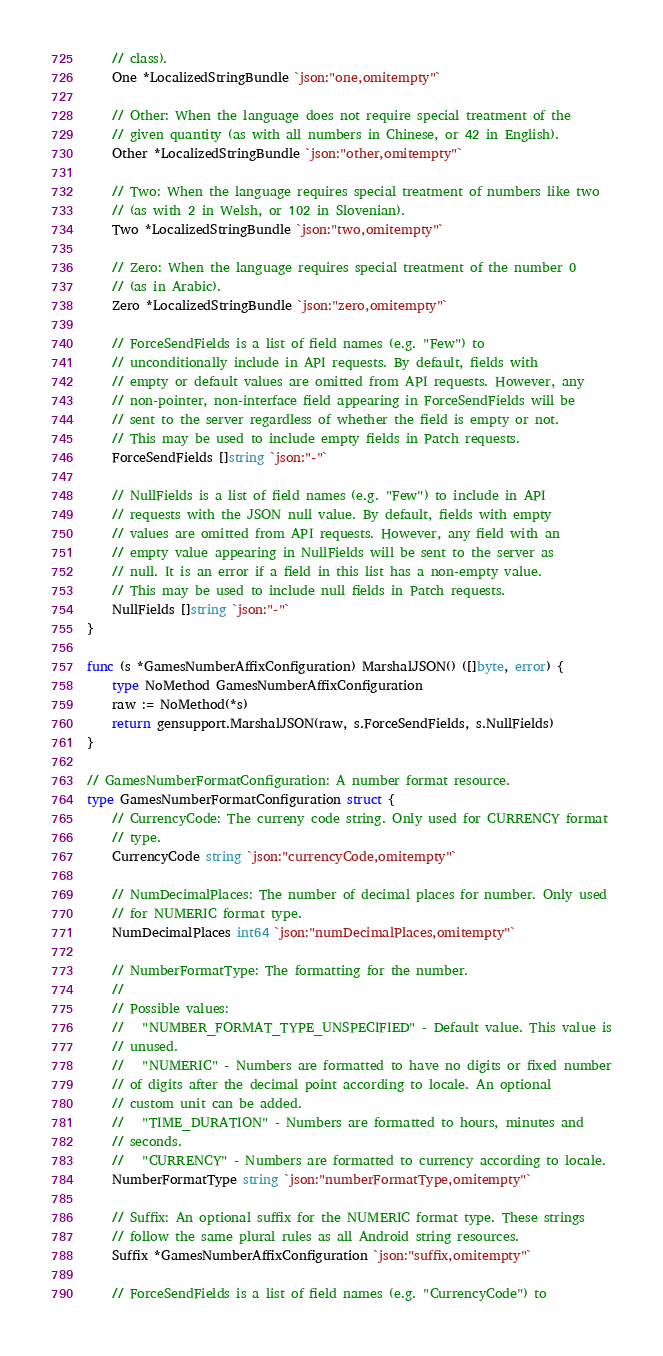Convert code to text. <code><loc_0><loc_0><loc_500><loc_500><_Go_>	// class).
	One *LocalizedStringBundle `json:"one,omitempty"`

	// Other: When the language does not require special treatment of the
	// given quantity (as with all numbers in Chinese, or 42 in English).
	Other *LocalizedStringBundle `json:"other,omitempty"`

	// Two: When the language requires special treatment of numbers like two
	// (as with 2 in Welsh, or 102 in Slovenian).
	Two *LocalizedStringBundle `json:"two,omitempty"`

	// Zero: When the language requires special treatment of the number 0
	// (as in Arabic).
	Zero *LocalizedStringBundle `json:"zero,omitempty"`

	// ForceSendFields is a list of field names (e.g. "Few") to
	// unconditionally include in API requests. By default, fields with
	// empty or default values are omitted from API requests. However, any
	// non-pointer, non-interface field appearing in ForceSendFields will be
	// sent to the server regardless of whether the field is empty or not.
	// This may be used to include empty fields in Patch requests.
	ForceSendFields []string `json:"-"`

	// NullFields is a list of field names (e.g. "Few") to include in API
	// requests with the JSON null value. By default, fields with empty
	// values are omitted from API requests. However, any field with an
	// empty value appearing in NullFields will be sent to the server as
	// null. It is an error if a field in this list has a non-empty value.
	// This may be used to include null fields in Patch requests.
	NullFields []string `json:"-"`
}

func (s *GamesNumberAffixConfiguration) MarshalJSON() ([]byte, error) {
	type NoMethod GamesNumberAffixConfiguration
	raw := NoMethod(*s)
	return gensupport.MarshalJSON(raw, s.ForceSendFields, s.NullFields)
}

// GamesNumberFormatConfiguration: A number format resource.
type GamesNumberFormatConfiguration struct {
	// CurrencyCode: The curreny code string. Only used for CURRENCY format
	// type.
	CurrencyCode string `json:"currencyCode,omitempty"`

	// NumDecimalPlaces: The number of decimal places for number. Only used
	// for NUMERIC format type.
	NumDecimalPlaces int64 `json:"numDecimalPlaces,omitempty"`

	// NumberFormatType: The formatting for the number.
	//
	// Possible values:
	//   "NUMBER_FORMAT_TYPE_UNSPECIFIED" - Default value. This value is
	// unused.
	//   "NUMERIC" - Numbers are formatted to have no digits or fixed number
	// of digits after the decimal point according to locale. An optional
	// custom unit can be added.
	//   "TIME_DURATION" - Numbers are formatted to hours, minutes and
	// seconds.
	//   "CURRENCY" - Numbers are formatted to currency according to locale.
	NumberFormatType string `json:"numberFormatType,omitempty"`

	// Suffix: An optional suffix for the NUMERIC format type. These strings
	// follow the same plural rules as all Android string resources.
	Suffix *GamesNumberAffixConfiguration `json:"suffix,omitempty"`

	// ForceSendFields is a list of field names (e.g. "CurrencyCode") to</code> 